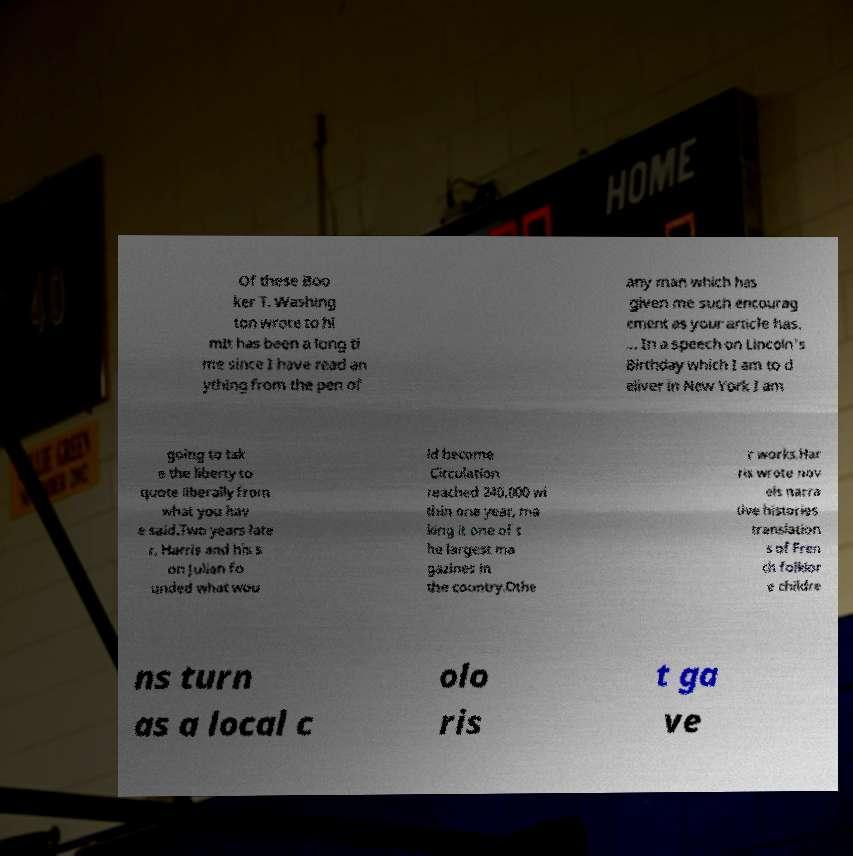Please identify and transcribe the text found in this image. Of these Boo ker T. Washing ton wrote to hi mIt has been a long ti me since I have read an ything from the pen of any man which has given me such encourag ement as your article has. ... In a speech on Lincoln's Birthday which I am to d eliver in New York I am going to tak e the liberty to quote liberally from what you hav e said.Two years late r, Harris and his s on Julian fo unded what wou ld become Circulation reached 240,000 wi thin one year, ma king it one of t he largest ma gazines in the country.Othe r works.Har ris wrote nov els narra tive histories translation s of Fren ch folklor e childre ns turn as a local c olo ris t ga ve 